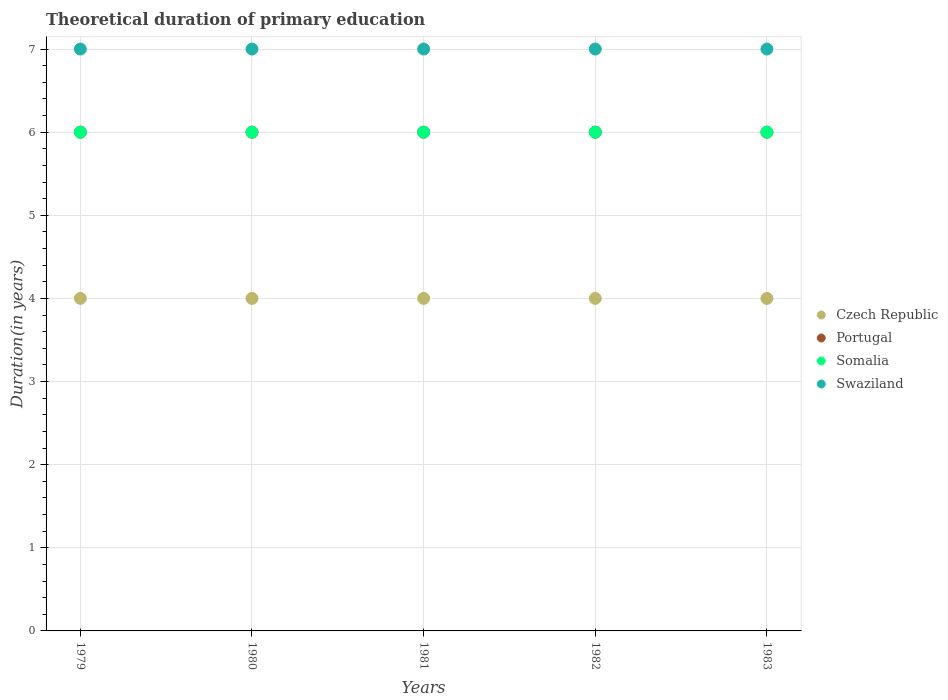How many different coloured dotlines are there?
Your answer should be very brief. 4. What is the total theoretical duration of primary education in Czech Republic in 1980?
Offer a very short reply. 4. Across all years, what is the maximum total theoretical duration of primary education in Czech Republic?
Make the answer very short. 4. In which year was the total theoretical duration of primary education in Czech Republic maximum?
Your response must be concise. 1979. In which year was the total theoretical duration of primary education in Portugal minimum?
Provide a succinct answer. 1979. What is the total total theoretical duration of primary education in Swaziland in the graph?
Give a very brief answer. 35. What is the difference between the total theoretical duration of primary education in Portugal in 1979 and the total theoretical duration of primary education in Swaziland in 1980?
Provide a short and direct response. -1. What is the average total theoretical duration of primary education in Swaziland per year?
Make the answer very short. 7. In the year 1982, what is the difference between the total theoretical duration of primary education in Czech Republic and total theoretical duration of primary education in Somalia?
Provide a short and direct response. -2. Is the total theoretical duration of primary education in Czech Republic in 1979 less than that in 1983?
Keep it short and to the point. No. Is the difference between the total theoretical duration of primary education in Czech Republic in 1981 and 1983 greater than the difference between the total theoretical duration of primary education in Somalia in 1981 and 1983?
Your response must be concise. No. What is the difference between the highest and the second highest total theoretical duration of primary education in Czech Republic?
Your answer should be very brief. 0. What is the difference between the highest and the lowest total theoretical duration of primary education in Portugal?
Provide a short and direct response. 0. Is it the case that in every year, the sum of the total theoretical duration of primary education in Portugal and total theoretical duration of primary education in Swaziland  is greater than the sum of total theoretical duration of primary education in Czech Republic and total theoretical duration of primary education in Somalia?
Your response must be concise. Yes. Does the total theoretical duration of primary education in Swaziland monotonically increase over the years?
Offer a terse response. No. Is the total theoretical duration of primary education in Czech Republic strictly less than the total theoretical duration of primary education in Portugal over the years?
Give a very brief answer. Yes. How many dotlines are there?
Provide a short and direct response. 4. What is the difference between two consecutive major ticks on the Y-axis?
Make the answer very short. 1. Are the values on the major ticks of Y-axis written in scientific E-notation?
Make the answer very short. No. Where does the legend appear in the graph?
Keep it short and to the point. Center right. How many legend labels are there?
Your answer should be compact. 4. How are the legend labels stacked?
Ensure brevity in your answer.  Vertical. What is the title of the graph?
Make the answer very short. Theoretical duration of primary education. What is the label or title of the X-axis?
Keep it short and to the point. Years. What is the label or title of the Y-axis?
Ensure brevity in your answer.  Duration(in years). What is the Duration(in years) in Czech Republic in 1979?
Make the answer very short. 4. What is the Duration(in years) in Portugal in 1979?
Make the answer very short. 6. What is the Duration(in years) in Swaziland in 1979?
Provide a short and direct response. 7. What is the Duration(in years) in Czech Republic in 1980?
Make the answer very short. 4. What is the Duration(in years) in Swaziland in 1980?
Provide a short and direct response. 7. What is the Duration(in years) of Czech Republic in 1981?
Offer a terse response. 4. What is the Duration(in years) of Portugal in 1981?
Ensure brevity in your answer.  6. What is the Duration(in years) of Somalia in 1981?
Keep it short and to the point. 6. What is the Duration(in years) of Portugal in 1982?
Your answer should be compact. 6. What is the Duration(in years) in Swaziland in 1982?
Keep it short and to the point. 7. What is the Duration(in years) of Czech Republic in 1983?
Ensure brevity in your answer.  4. What is the Duration(in years) of Portugal in 1983?
Provide a short and direct response. 6. What is the Duration(in years) in Somalia in 1983?
Offer a very short reply. 6. What is the Duration(in years) in Swaziland in 1983?
Make the answer very short. 7. Across all years, what is the maximum Duration(in years) of Somalia?
Keep it short and to the point. 6. What is the total Duration(in years) in Czech Republic in the graph?
Your answer should be very brief. 20. What is the total Duration(in years) in Portugal in the graph?
Ensure brevity in your answer.  30. What is the total Duration(in years) in Somalia in the graph?
Make the answer very short. 30. What is the total Duration(in years) of Swaziland in the graph?
Provide a succinct answer. 35. What is the difference between the Duration(in years) in Portugal in 1979 and that in 1980?
Provide a short and direct response. 0. What is the difference between the Duration(in years) of Somalia in 1979 and that in 1980?
Ensure brevity in your answer.  0. What is the difference between the Duration(in years) in Swaziland in 1979 and that in 1980?
Your answer should be very brief. 0. What is the difference between the Duration(in years) in Somalia in 1979 and that in 1981?
Your answer should be compact. 0. What is the difference between the Duration(in years) of Czech Republic in 1979 and that in 1982?
Your answer should be very brief. 0. What is the difference between the Duration(in years) in Portugal in 1979 and that in 1982?
Provide a short and direct response. 0. What is the difference between the Duration(in years) of Swaziland in 1979 and that in 1982?
Offer a very short reply. 0. What is the difference between the Duration(in years) in Czech Republic in 1979 and that in 1983?
Your answer should be compact. 0. What is the difference between the Duration(in years) of Portugal in 1979 and that in 1983?
Your response must be concise. 0. What is the difference between the Duration(in years) of Somalia in 1979 and that in 1983?
Your answer should be compact. 0. What is the difference between the Duration(in years) of Somalia in 1980 and that in 1981?
Offer a terse response. 0. What is the difference between the Duration(in years) in Swaziland in 1980 and that in 1981?
Offer a very short reply. 0. What is the difference between the Duration(in years) in Czech Republic in 1980 and that in 1982?
Provide a succinct answer. 0. What is the difference between the Duration(in years) of Portugal in 1980 and that in 1982?
Offer a terse response. 0. What is the difference between the Duration(in years) of Somalia in 1980 and that in 1982?
Provide a short and direct response. 0. What is the difference between the Duration(in years) of Swaziland in 1980 and that in 1982?
Provide a succinct answer. 0. What is the difference between the Duration(in years) in Portugal in 1980 and that in 1983?
Give a very brief answer. 0. What is the difference between the Duration(in years) of Somalia in 1980 and that in 1983?
Your response must be concise. 0. What is the difference between the Duration(in years) in Swaziland in 1980 and that in 1983?
Provide a succinct answer. 0. What is the difference between the Duration(in years) in Swaziland in 1981 and that in 1982?
Give a very brief answer. 0. What is the difference between the Duration(in years) of Portugal in 1981 and that in 1983?
Your answer should be compact. 0. What is the difference between the Duration(in years) of Swaziland in 1981 and that in 1983?
Keep it short and to the point. 0. What is the difference between the Duration(in years) in Czech Republic in 1982 and that in 1983?
Your answer should be compact. 0. What is the difference between the Duration(in years) in Portugal in 1982 and that in 1983?
Ensure brevity in your answer.  0. What is the difference between the Duration(in years) in Czech Republic in 1979 and the Duration(in years) in Portugal in 1980?
Provide a short and direct response. -2. What is the difference between the Duration(in years) in Czech Republic in 1979 and the Duration(in years) in Swaziland in 1980?
Offer a very short reply. -3. What is the difference between the Duration(in years) in Portugal in 1979 and the Duration(in years) in Somalia in 1980?
Keep it short and to the point. 0. What is the difference between the Duration(in years) in Portugal in 1979 and the Duration(in years) in Swaziland in 1980?
Your answer should be very brief. -1. What is the difference between the Duration(in years) in Czech Republic in 1979 and the Duration(in years) in Somalia in 1981?
Your answer should be very brief. -2. What is the difference between the Duration(in years) in Somalia in 1979 and the Duration(in years) in Swaziland in 1981?
Offer a very short reply. -1. What is the difference between the Duration(in years) in Czech Republic in 1979 and the Duration(in years) in Portugal in 1982?
Your answer should be very brief. -2. What is the difference between the Duration(in years) of Czech Republic in 1979 and the Duration(in years) of Somalia in 1982?
Offer a very short reply. -2. What is the difference between the Duration(in years) in Portugal in 1979 and the Duration(in years) in Somalia in 1982?
Offer a very short reply. 0. What is the difference between the Duration(in years) in Portugal in 1979 and the Duration(in years) in Swaziland in 1982?
Your answer should be very brief. -1. What is the difference between the Duration(in years) of Czech Republic in 1979 and the Duration(in years) of Somalia in 1983?
Provide a succinct answer. -2. What is the difference between the Duration(in years) in Czech Republic in 1979 and the Duration(in years) in Swaziland in 1983?
Provide a succinct answer. -3. What is the difference between the Duration(in years) of Portugal in 1979 and the Duration(in years) of Somalia in 1983?
Make the answer very short. 0. What is the difference between the Duration(in years) in Czech Republic in 1980 and the Duration(in years) in Somalia in 1981?
Keep it short and to the point. -2. What is the difference between the Duration(in years) of Portugal in 1980 and the Duration(in years) of Swaziland in 1981?
Provide a short and direct response. -1. What is the difference between the Duration(in years) in Somalia in 1980 and the Duration(in years) in Swaziland in 1981?
Your answer should be compact. -1. What is the difference between the Duration(in years) in Czech Republic in 1980 and the Duration(in years) in Portugal in 1982?
Make the answer very short. -2. What is the difference between the Duration(in years) of Czech Republic in 1980 and the Duration(in years) of Somalia in 1982?
Offer a terse response. -2. What is the difference between the Duration(in years) of Czech Republic in 1980 and the Duration(in years) of Swaziland in 1982?
Give a very brief answer. -3. What is the difference between the Duration(in years) of Portugal in 1980 and the Duration(in years) of Somalia in 1982?
Provide a short and direct response. 0. What is the difference between the Duration(in years) of Czech Republic in 1980 and the Duration(in years) of Swaziland in 1983?
Your response must be concise. -3. What is the difference between the Duration(in years) of Portugal in 1980 and the Duration(in years) of Somalia in 1983?
Make the answer very short. 0. What is the difference between the Duration(in years) in Portugal in 1980 and the Duration(in years) in Swaziland in 1983?
Ensure brevity in your answer.  -1. What is the difference between the Duration(in years) in Somalia in 1980 and the Duration(in years) in Swaziland in 1983?
Offer a very short reply. -1. What is the difference between the Duration(in years) in Czech Republic in 1981 and the Duration(in years) in Somalia in 1982?
Your answer should be compact. -2. What is the difference between the Duration(in years) in Portugal in 1981 and the Duration(in years) in Swaziland in 1982?
Provide a short and direct response. -1. What is the difference between the Duration(in years) of Czech Republic in 1981 and the Duration(in years) of Portugal in 1983?
Offer a very short reply. -2. What is the difference between the Duration(in years) in Czech Republic in 1981 and the Duration(in years) in Somalia in 1983?
Provide a short and direct response. -2. What is the difference between the Duration(in years) in Czech Republic in 1981 and the Duration(in years) in Swaziland in 1983?
Your response must be concise. -3. What is the difference between the Duration(in years) of Czech Republic in 1982 and the Duration(in years) of Somalia in 1983?
Offer a very short reply. -2. What is the difference between the Duration(in years) of Czech Republic in 1982 and the Duration(in years) of Swaziland in 1983?
Offer a terse response. -3. What is the difference between the Duration(in years) of Portugal in 1982 and the Duration(in years) of Swaziland in 1983?
Keep it short and to the point. -1. What is the difference between the Duration(in years) of Somalia in 1982 and the Duration(in years) of Swaziland in 1983?
Your answer should be compact. -1. What is the average Duration(in years) of Portugal per year?
Give a very brief answer. 6. What is the average Duration(in years) of Somalia per year?
Ensure brevity in your answer.  6. In the year 1979, what is the difference between the Duration(in years) in Czech Republic and Duration(in years) in Somalia?
Your answer should be very brief. -2. In the year 1979, what is the difference between the Duration(in years) in Portugal and Duration(in years) in Swaziland?
Provide a succinct answer. -1. In the year 1979, what is the difference between the Duration(in years) of Somalia and Duration(in years) of Swaziland?
Keep it short and to the point. -1. In the year 1980, what is the difference between the Duration(in years) in Czech Republic and Duration(in years) in Swaziland?
Give a very brief answer. -3. In the year 1980, what is the difference between the Duration(in years) of Portugal and Duration(in years) of Somalia?
Your answer should be very brief. 0. In the year 1980, what is the difference between the Duration(in years) in Portugal and Duration(in years) in Swaziland?
Make the answer very short. -1. In the year 1981, what is the difference between the Duration(in years) of Czech Republic and Duration(in years) of Portugal?
Ensure brevity in your answer.  -2. In the year 1981, what is the difference between the Duration(in years) of Portugal and Duration(in years) of Swaziland?
Provide a succinct answer. -1. In the year 1981, what is the difference between the Duration(in years) in Somalia and Duration(in years) in Swaziland?
Make the answer very short. -1. In the year 1982, what is the difference between the Duration(in years) in Portugal and Duration(in years) in Somalia?
Keep it short and to the point. 0. In the year 1982, what is the difference between the Duration(in years) of Portugal and Duration(in years) of Swaziland?
Keep it short and to the point. -1. In the year 1983, what is the difference between the Duration(in years) in Czech Republic and Duration(in years) in Portugal?
Provide a succinct answer. -2. In the year 1983, what is the difference between the Duration(in years) in Czech Republic and Duration(in years) in Swaziland?
Your answer should be compact. -3. In the year 1983, what is the difference between the Duration(in years) of Portugal and Duration(in years) of Somalia?
Give a very brief answer. 0. In the year 1983, what is the difference between the Duration(in years) of Somalia and Duration(in years) of Swaziland?
Give a very brief answer. -1. What is the ratio of the Duration(in years) in Swaziland in 1979 to that in 1981?
Give a very brief answer. 1. What is the ratio of the Duration(in years) in Czech Republic in 1979 to that in 1982?
Your answer should be compact. 1. What is the ratio of the Duration(in years) of Portugal in 1979 to that in 1982?
Offer a terse response. 1. What is the ratio of the Duration(in years) in Somalia in 1979 to that in 1982?
Provide a succinct answer. 1. What is the ratio of the Duration(in years) in Czech Republic in 1979 to that in 1983?
Your answer should be compact. 1. What is the ratio of the Duration(in years) of Swaziland in 1979 to that in 1983?
Offer a very short reply. 1. What is the ratio of the Duration(in years) of Portugal in 1980 to that in 1981?
Offer a terse response. 1. What is the ratio of the Duration(in years) of Portugal in 1980 to that in 1982?
Your answer should be very brief. 1. What is the ratio of the Duration(in years) of Somalia in 1980 to that in 1982?
Make the answer very short. 1. What is the ratio of the Duration(in years) of Czech Republic in 1981 to that in 1982?
Give a very brief answer. 1. What is the ratio of the Duration(in years) of Portugal in 1981 to that in 1982?
Offer a very short reply. 1. What is the ratio of the Duration(in years) in Somalia in 1981 to that in 1982?
Your response must be concise. 1. What is the ratio of the Duration(in years) of Swaziland in 1981 to that in 1982?
Give a very brief answer. 1. What is the ratio of the Duration(in years) in Czech Republic in 1981 to that in 1983?
Your answer should be very brief. 1. What is the ratio of the Duration(in years) of Portugal in 1981 to that in 1983?
Provide a succinct answer. 1. What is the ratio of the Duration(in years) of Swaziland in 1981 to that in 1983?
Offer a terse response. 1. What is the ratio of the Duration(in years) of Portugal in 1982 to that in 1983?
Make the answer very short. 1. What is the ratio of the Duration(in years) of Swaziland in 1982 to that in 1983?
Your response must be concise. 1. What is the difference between the highest and the lowest Duration(in years) of Czech Republic?
Keep it short and to the point. 0. What is the difference between the highest and the lowest Duration(in years) of Portugal?
Your response must be concise. 0. What is the difference between the highest and the lowest Duration(in years) in Swaziland?
Offer a very short reply. 0. 